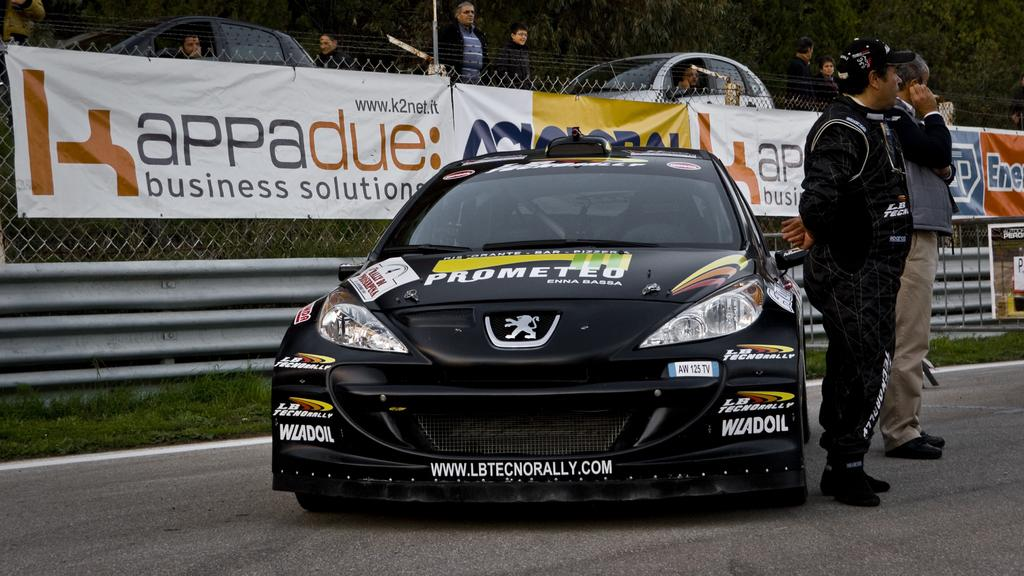How many people are present in the image? There are two people standing in the image. What can be seen on the road in the image? There is a car on the road in the image. What type of vegetation is visible in the image? Grass is visible in the image. Can you describe the background of the image? In the background of the image, there are people, a fence, banners, cars, and trees. What type of knowledge is being shared between the two people in the image? There is no indication in the image of any knowledge being shared between the two people. How does the fence support the trees in the background of the image? The image does not show the fence supporting the trees; it is simply a background element. 